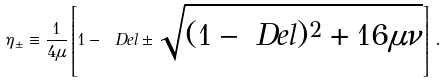<formula> <loc_0><loc_0><loc_500><loc_500>\eta _ { \pm } \equiv \frac { 1 } { 4 \mu } \left [ 1 - \ D e l \pm \sqrt { ( 1 - \ D e l ) ^ { 2 } + 1 6 \mu \nu } \right ] \, .</formula> 